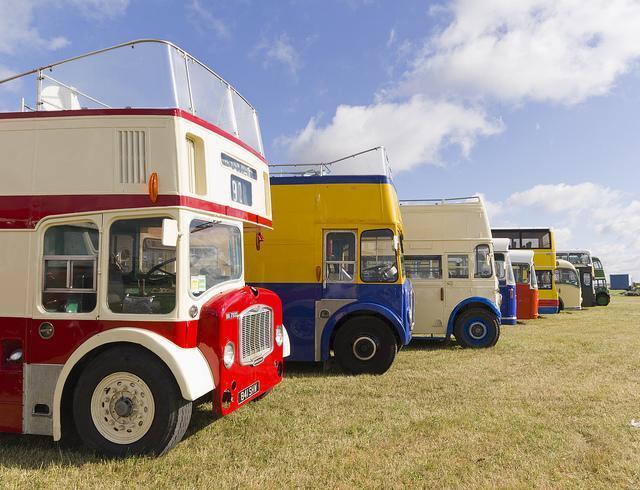How many buses are visible?
Give a very brief answer. 4. How many people are wearing hat?
Give a very brief answer. 0. 